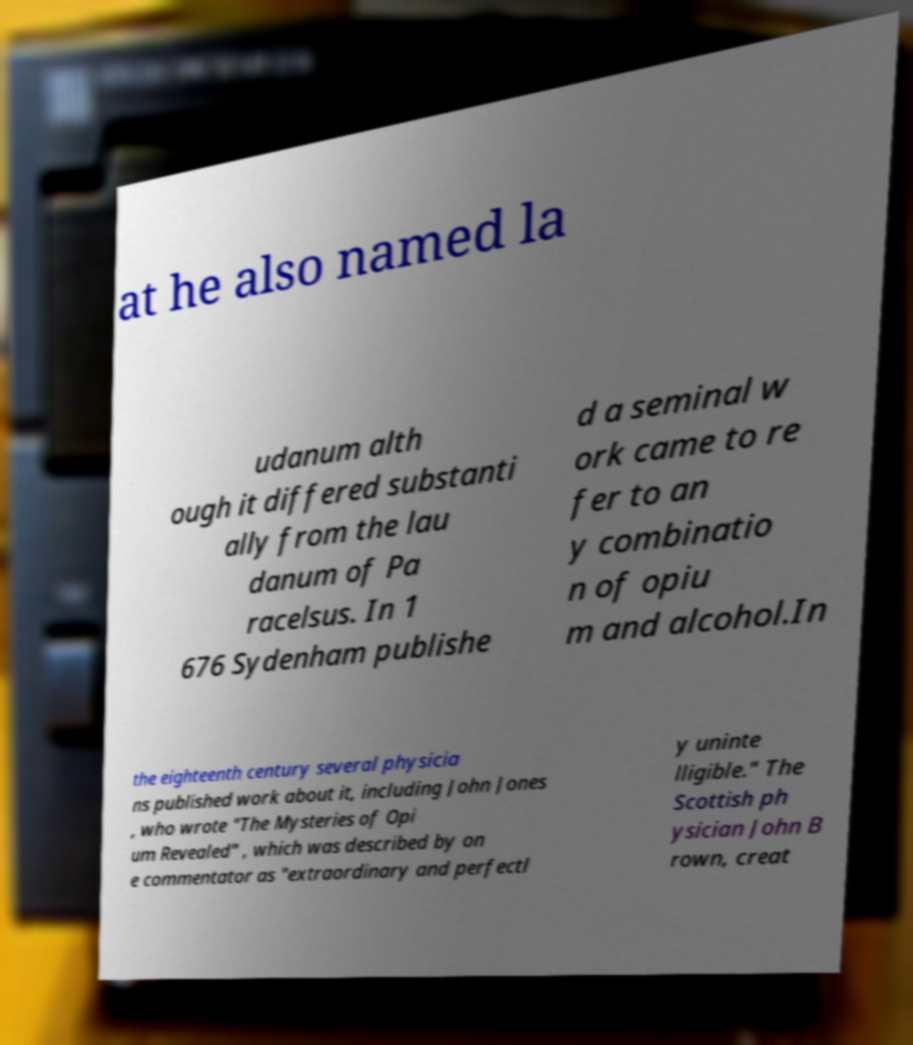What messages or text are displayed in this image? I need them in a readable, typed format. at he also named la udanum alth ough it differed substanti ally from the lau danum of Pa racelsus. In 1 676 Sydenham publishe d a seminal w ork came to re fer to an y combinatio n of opiu m and alcohol.In the eighteenth century several physicia ns published work about it, including John Jones , who wrote "The Mysteries of Opi um Revealed" , which was described by on e commentator as "extraordinary and perfectl y uninte lligible." The Scottish ph ysician John B rown, creat 